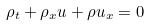Convert formula to latex. <formula><loc_0><loc_0><loc_500><loc_500>\rho _ { t } + \rho _ { x } u + \rho u _ { x } = 0</formula> 